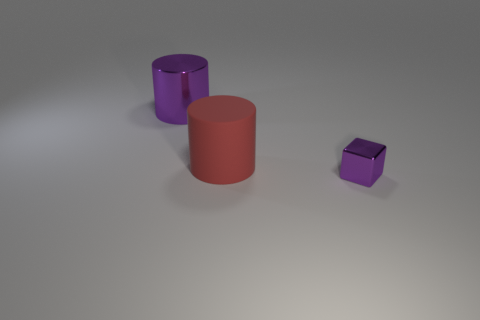Add 1 rubber things. How many objects exist? 4 Subtract all cylinders. How many objects are left? 1 Add 1 red matte cylinders. How many red matte cylinders are left? 2 Add 1 red objects. How many red objects exist? 2 Subtract 0 cyan cylinders. How many objects are left? 3 Subtract all red matte cylinders. Subtract all gray cubes. How many objects are left? 2 